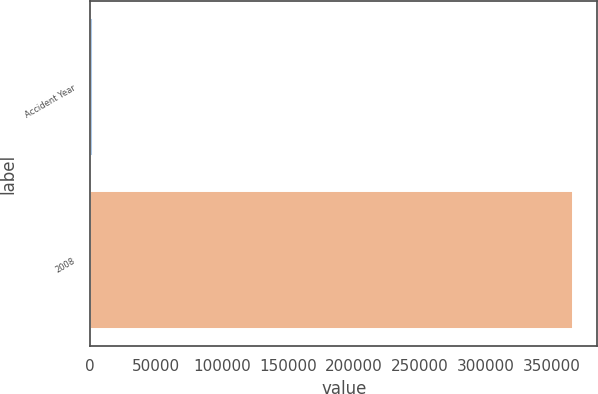Convert chart to OTSL. <chart><loc_0><loc_0><loc_500><loc_500><bar_chart><fcel>Accident Year<fcel>2008<nl><fcel>2015<fcel>366389<nl></chart> 